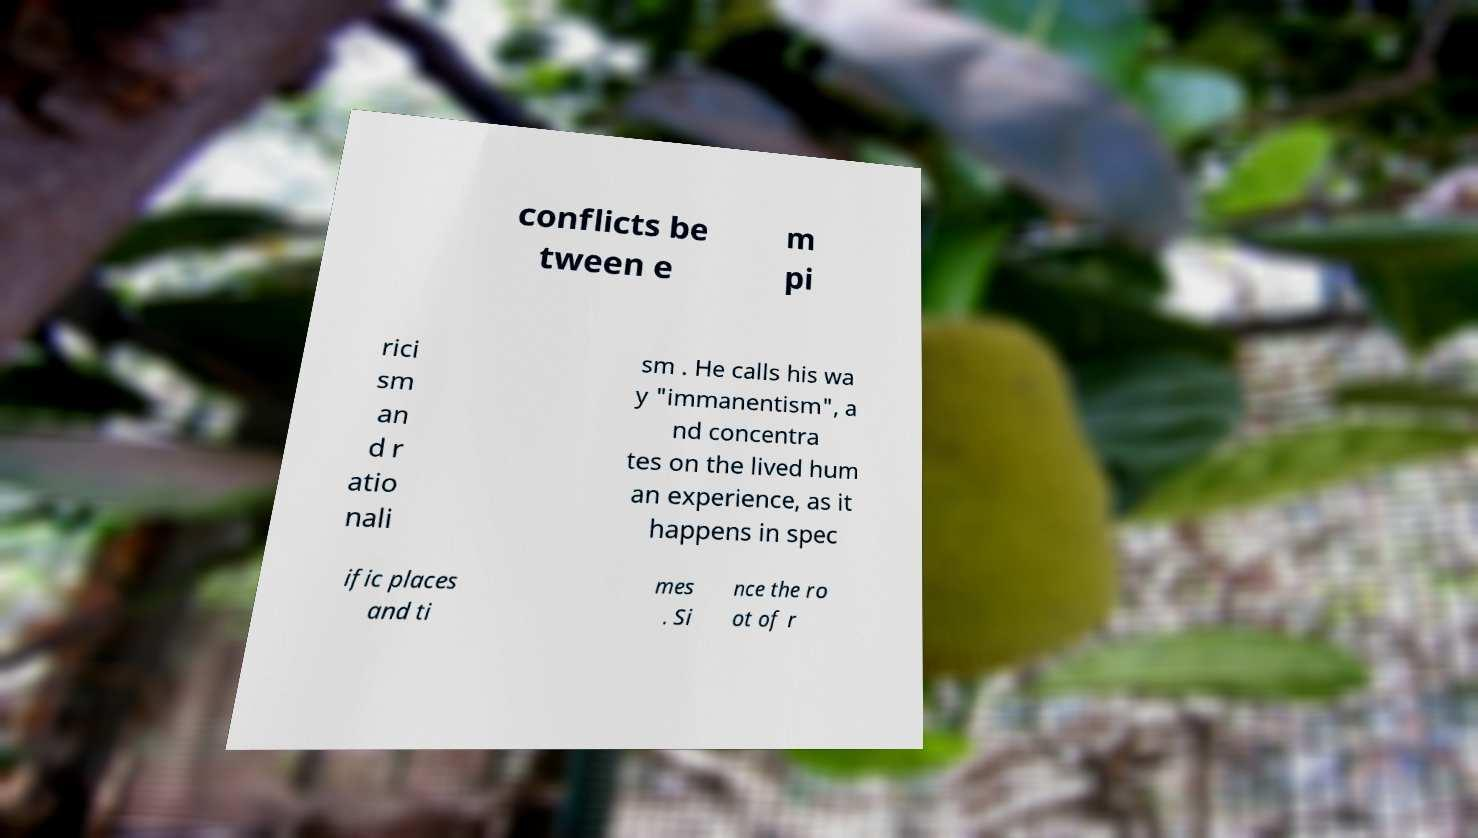For documentation purposes, I need the text within this image transcribed. Could you provide that? conflicts be tween e m pi rici sm an d r atio nali sm . He calls his wa y "immanentism", a nd concentra tes on the lived hum an experience, as it happens in spec ific places and ti mes . Si nce the ro ot of r 